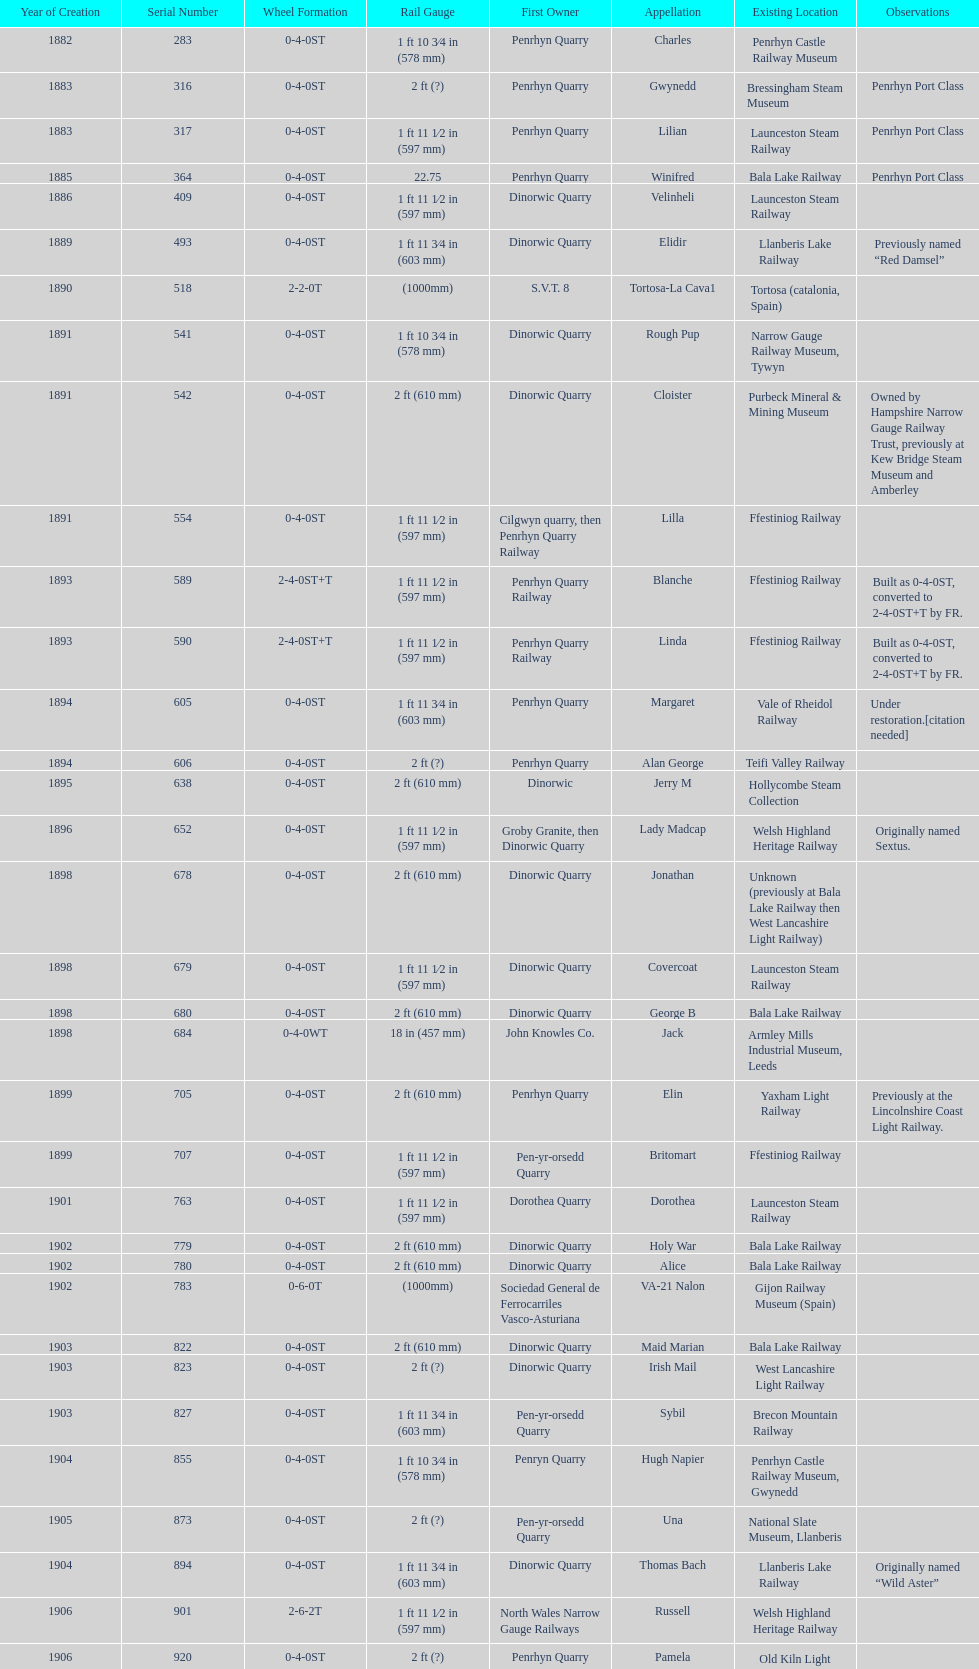What is the works number of the only item built in 1882? 283. 